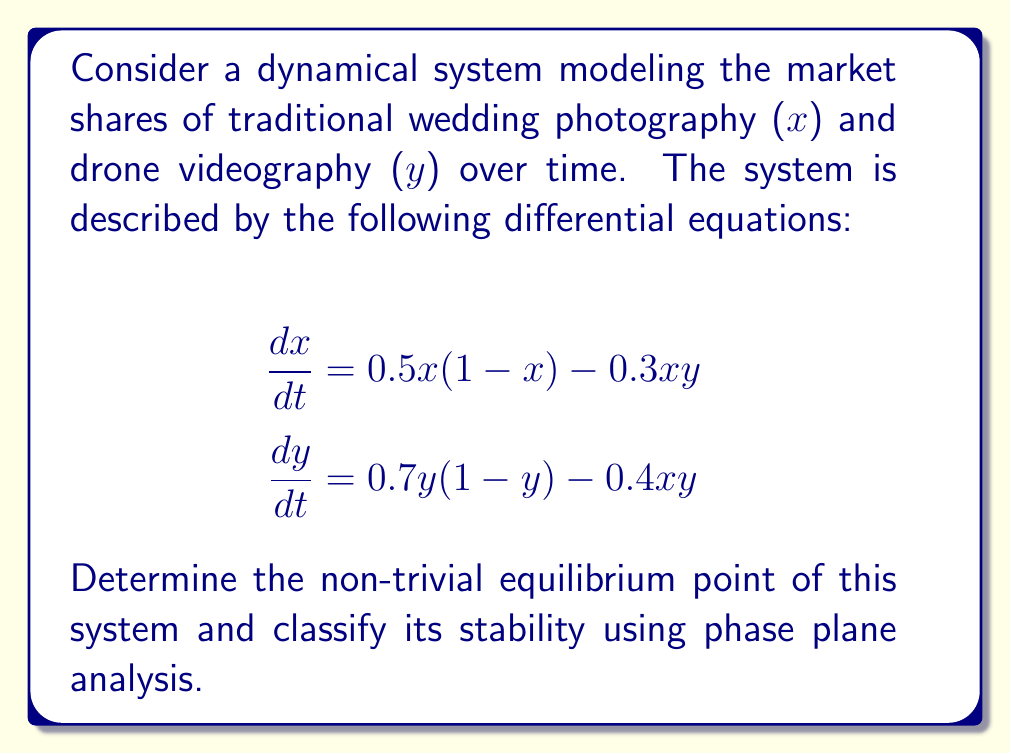Could you help me with this problem? 1. To find the equilibrium points, set both equations to zero:

   $$0.5x(1-x) - 0.3xy = 0$$
   $$0.7y(1-y) - 0.4xy = 0$$

2. Factor out $x$ and $y$ from each equation:

   $$x(0.5 - 0.5x - 0.3y) = 0$$
   $$y(0.7 - 0.7y - 0.4x) = 0$$

3. The trivial equilibrium point is (0,0). For non-trivial points, solve:

   $$0.5 - 0.5x - 0.3y = 0$$
   $$0.7 - 0.7y - 0.4x = 0$$

4. From the first equation:
   $$x = 1 - 0.6y$$

5. Substitute into the second equation:
   $$0.7 - 0.7y - 0.4(1 - 0.6y) = 0$$
   $$0.7 - 0.7y - 0.4 + 0.24y = 0$$
   $$0.3 - 0.46y = 0$$
   $$y = \frac{0.3}{0.46} \approx 0.652$$

6. Substitute back to find $x$:
   $$x = 1 - 0.6(0.652) \approx 0.609$$

7. To classify stability, compute the Jacobian matrix at (0.609, 0.652):

   $$J = \begin{bmatrix}
   0.5 - x - 0.3y & -0.3x \\
   -0.4y & 0.7 - 1.4y - 0.4x
   \end{bmatrix}$$

8. Evaluate the Jacobian:

   $$J \approx \begin{bmatrix}
   -0.196 & -0.183 \\
   -0.261 & -0.261
   \end{bmatrix}$$

9. Calculate the determinant and trace:
   $$\det(J) \approx 0.051 > 0$$
   $$\text{tr}(J) \approx -0.457 < 0$$

10. Since det(J) > 0 and tr(J) < 0, the equilibrium point is a stable spiral.
Answer: Non-trivial equilibrium point: (0.609, 0.652), stable spiral. 